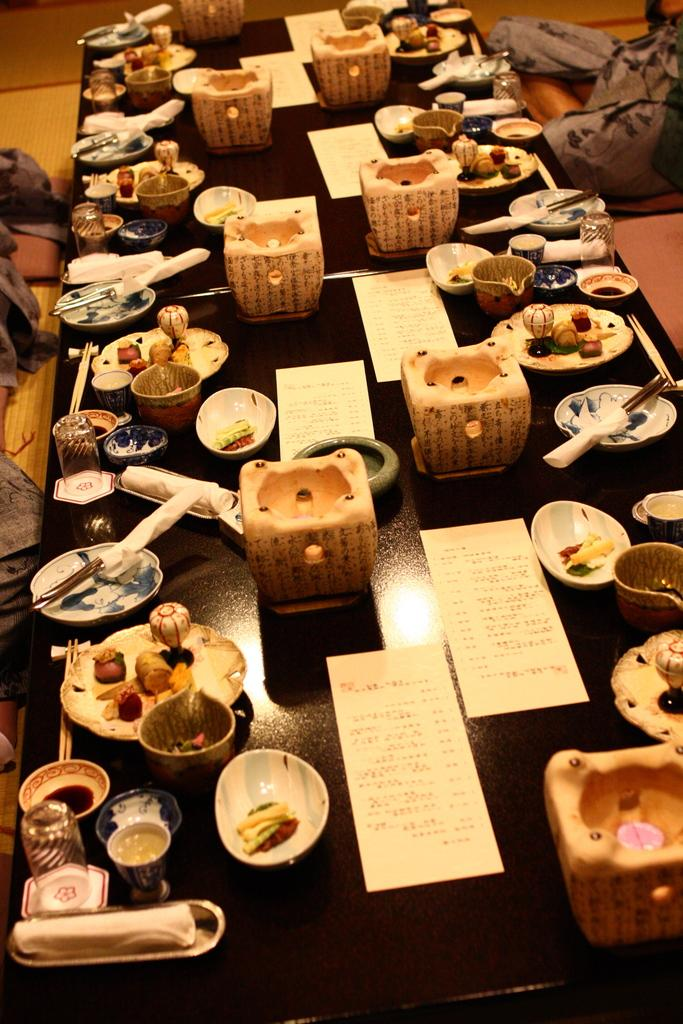What objects are on the table in the image? There are cards, bowls, plates, jars, and chopsticks on the table. What type of utensils are present on the table? Chopsticks are present on the table. What else can be seen on the table besides the utensils? There are cards, bowls, and plates on the table. Are there any objects visible in the background of the image? Yes, there are objects visible in the background. What type of ornament is hanging from the ceiling in the image? There is no ornament hanging from the ceiling in the image. What language is spoken by the people in the image? The image does not depict any people, so it is impossible to determine the language spoken. 